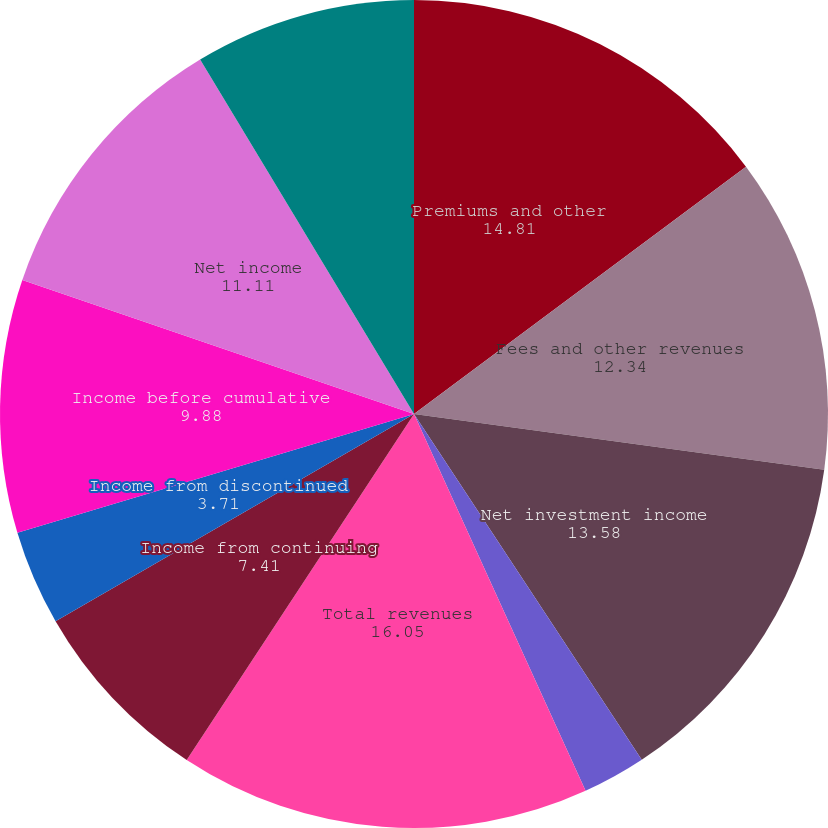Convert chart. <chart><loc_0><loc_0><loc_500><loc_500><pie_chart><fcel>Premiums and other<fcel>Fees and other revenues<fcel>Net investment income<fcel>Net realized/unrealized<fcel>Total revenues<fcel>Income from continuing<fcel>Income from discontinued<fcel>Income before cumulative<fcel>Net income<fcel>Net income available to common<nl><fcel>14.81%<fcel>12.34%<fcel>13.58%<fcel>2.47%<fcel>16.05%<fcel>7.41%<fcel>3.71%<fcel>9.88%<fcel>11.11%<fcel>8.64%<nl></chart> 